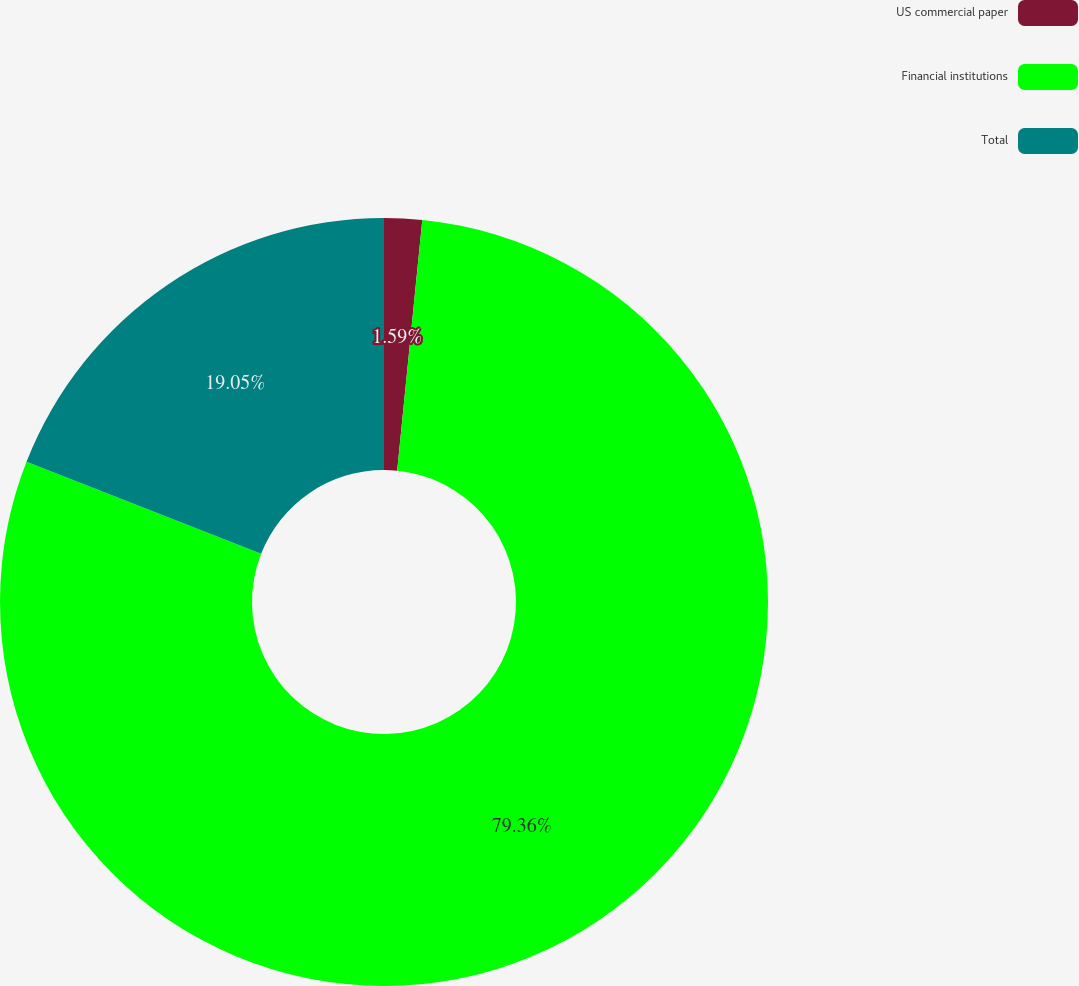Convert chart to OTSL. <chart><loc_0><loc_0><loc_500><loc_500><pie_chart><fcel>US commercial paper<fcel>Financial institutions<fcel>Total<nl><fcel>1.59%<fcel>79.37%<fcel>19.05%<nl></chart> 